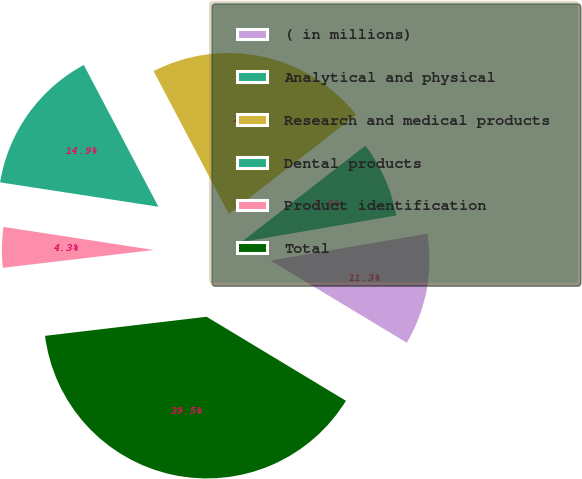<chart> <loc_0><loc_0><loc_500><loc_500><pie_chart><fcel>( in millions)<fcel>Analytical and physical<fcel>Research and medical products<fcel>Dental products<fcel>Product identification<fcel>Total<nl><fcel>11.34%<fcel>7.82%<fcel>22.19%<fcel>14.86%<fcel>4.3%<fcel>39.49%<nl></chart> 